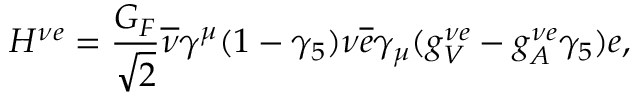Convert formula to latex. <formula><loc_0><loc_0><loc_500><loc_500>H ^ { \nu e } = \frac { G _ { F } } { \sqrt { 2 } } \overline { \nu } \gamma ^ { \mu } ( 1 - \gamma _ { 5 } ) \nu \overline { e } \gamma _ { \mu } ( g _ { V } ^ { \nu e } - g _ { A } ^ { \nu e } \gamma _ { 5 } ) e ,</formula> 